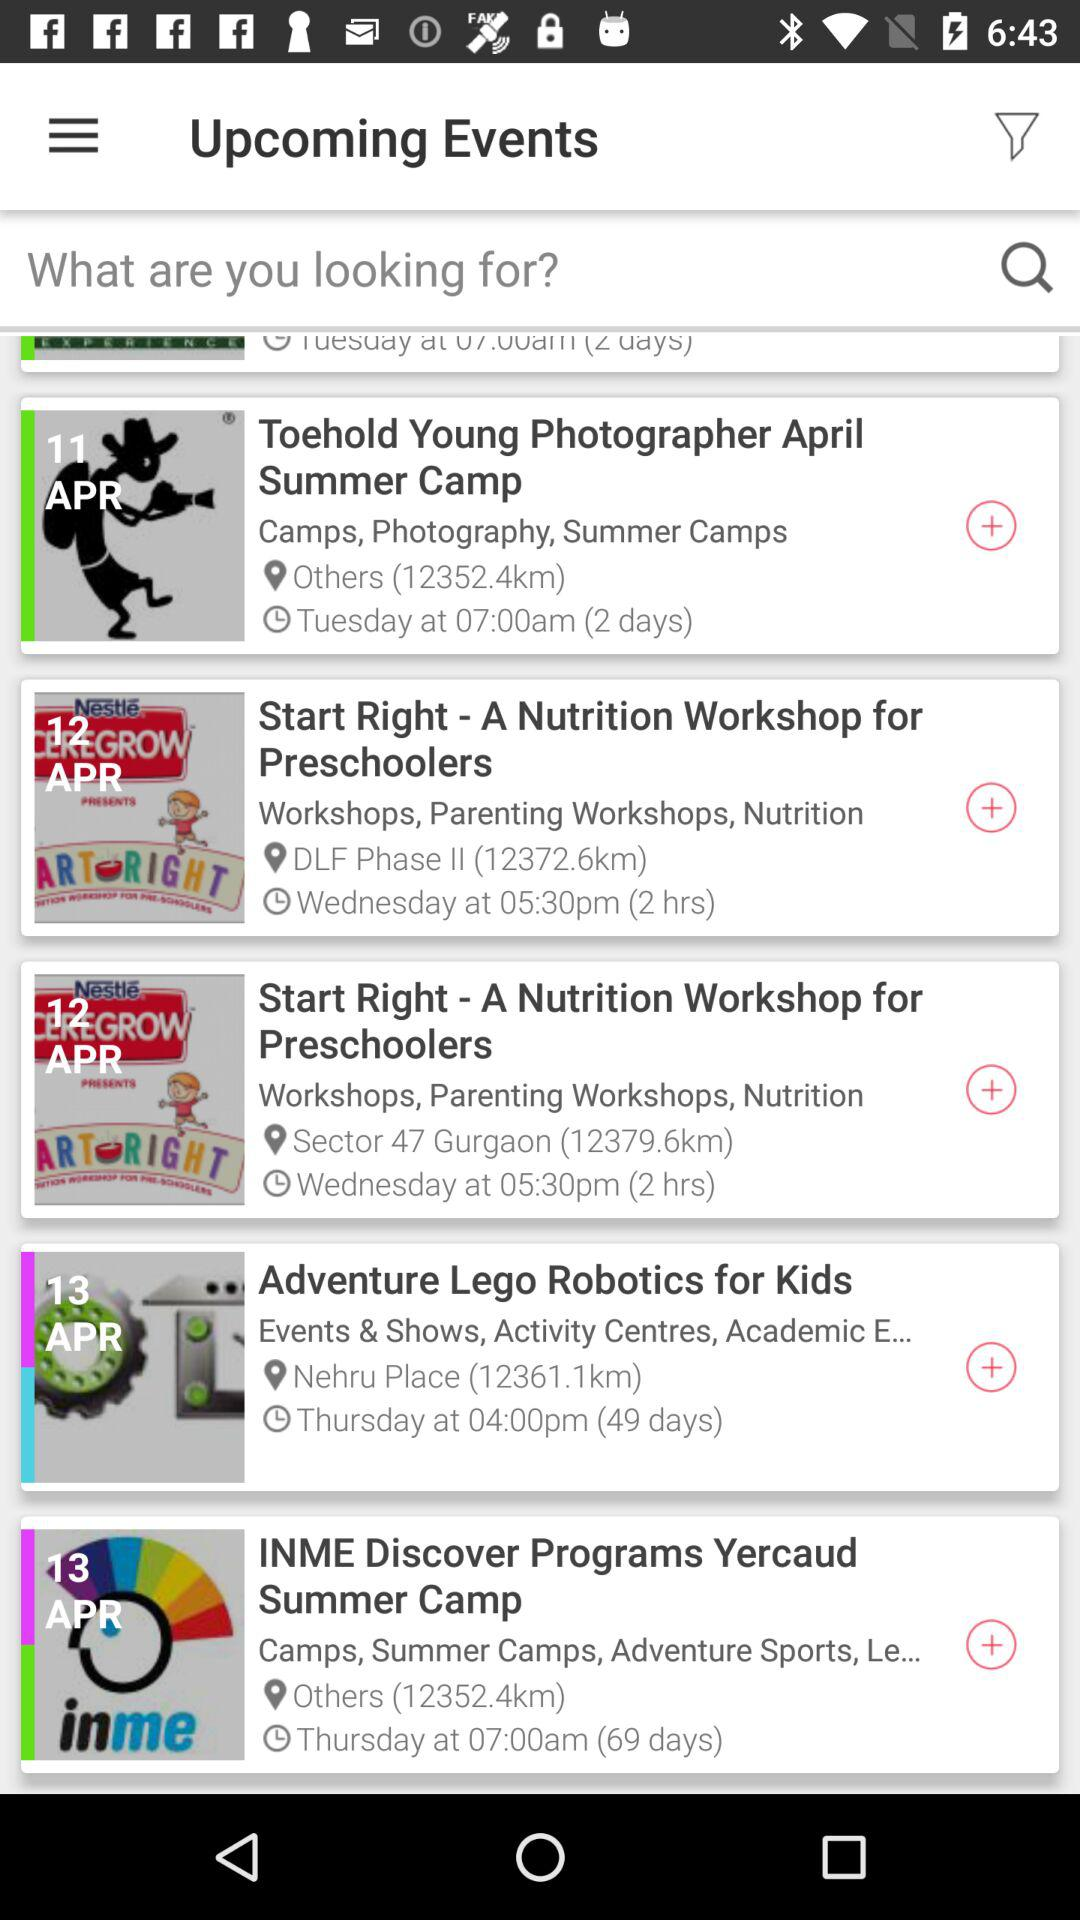What is the timing of "Start Right - A Nutrition Workshop for Preschoolers"? The time is 5:30 pm. 